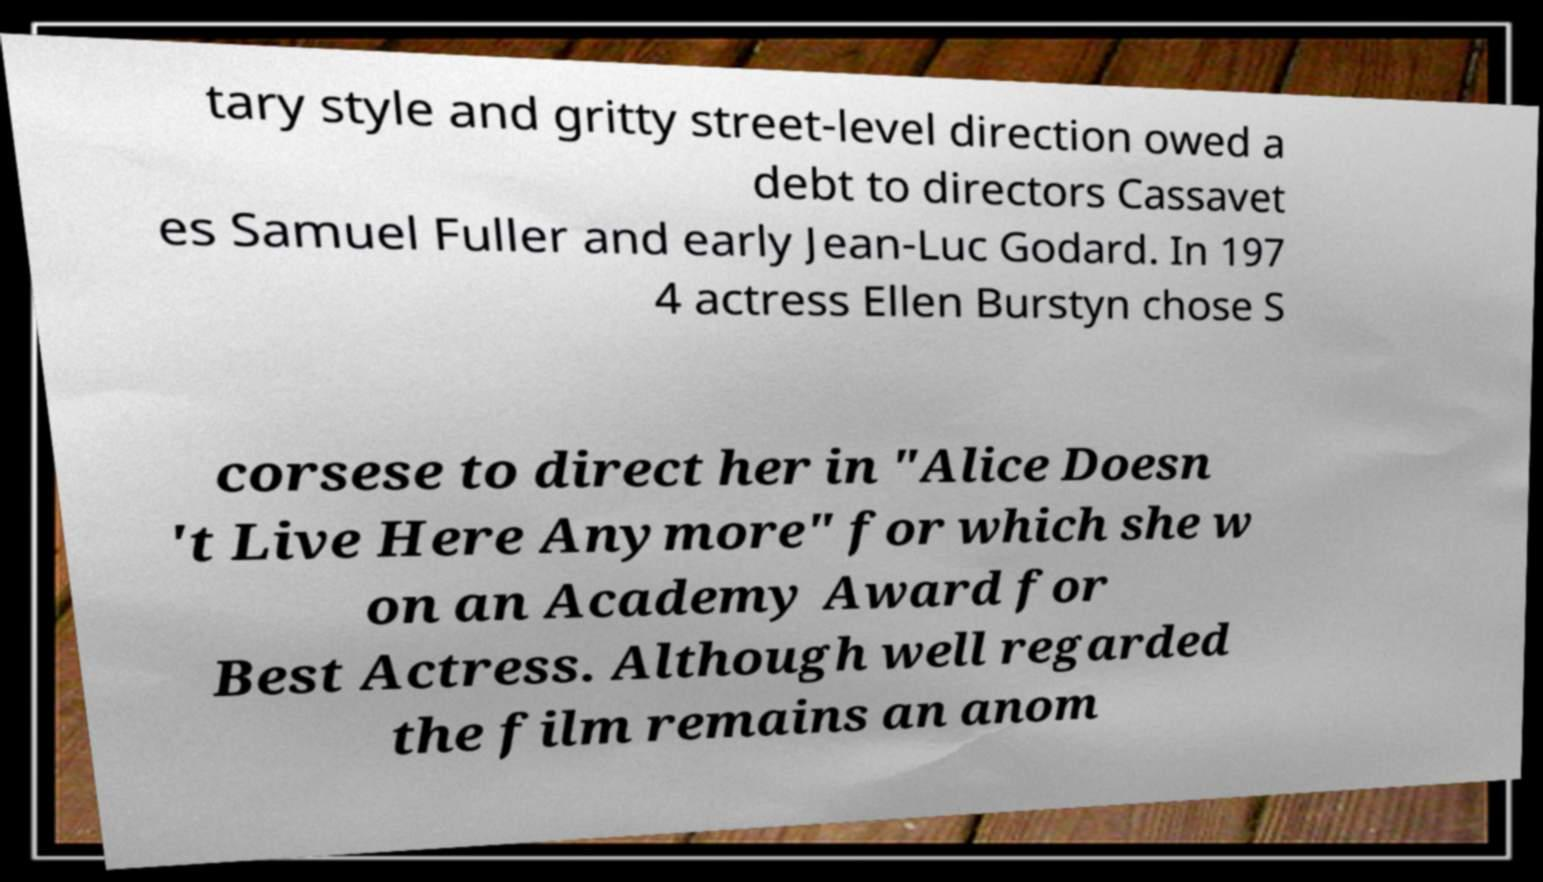Could you assist in decoding the text presented in this image and type it out clearly? tary style and gritty street-level direction owed a debt to directors Cassavet es Samuel Fuller and early Jean-Luc Godard. In 197 4 actress Ellen Burstyn chose S corsese to direct her in "Alice Doesn 't Live Here Anymore" for which she w on an Academy Award for Best Actress. Although well regarded the film remains an anom 